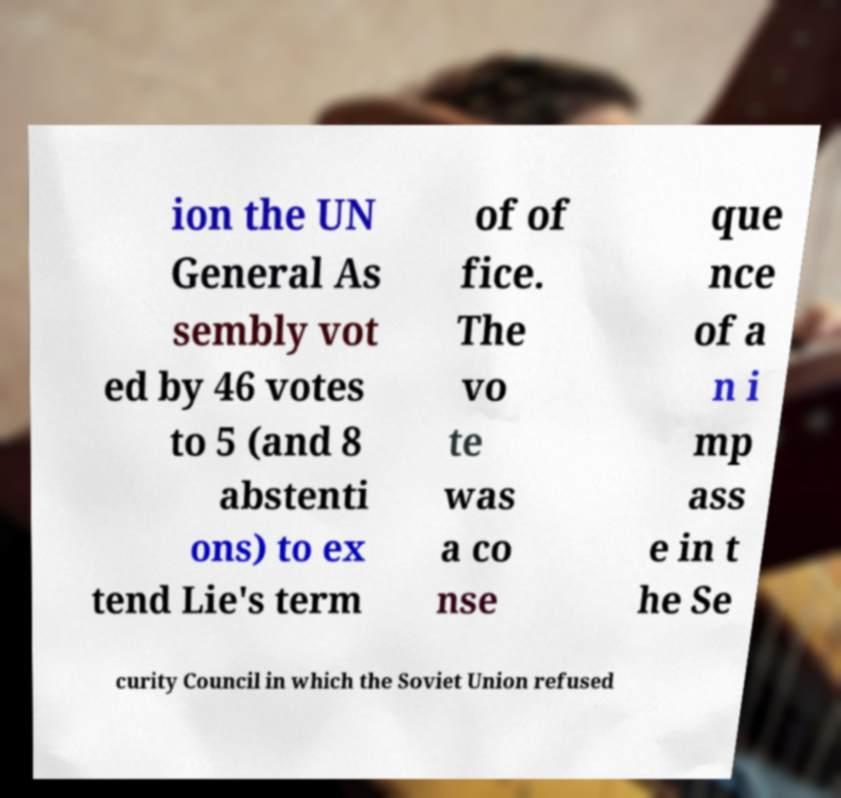I need the written content from this picture converted into text. Can you do that? ion the UN General As sembly vot ed by 46 votes to 5 (and 8 abstenti ons) to ex tend Lie's term of of fice. The vo te was a co nse que nce of a n i mp ass e in t he Se curity Council in which the Soviet Union refused 